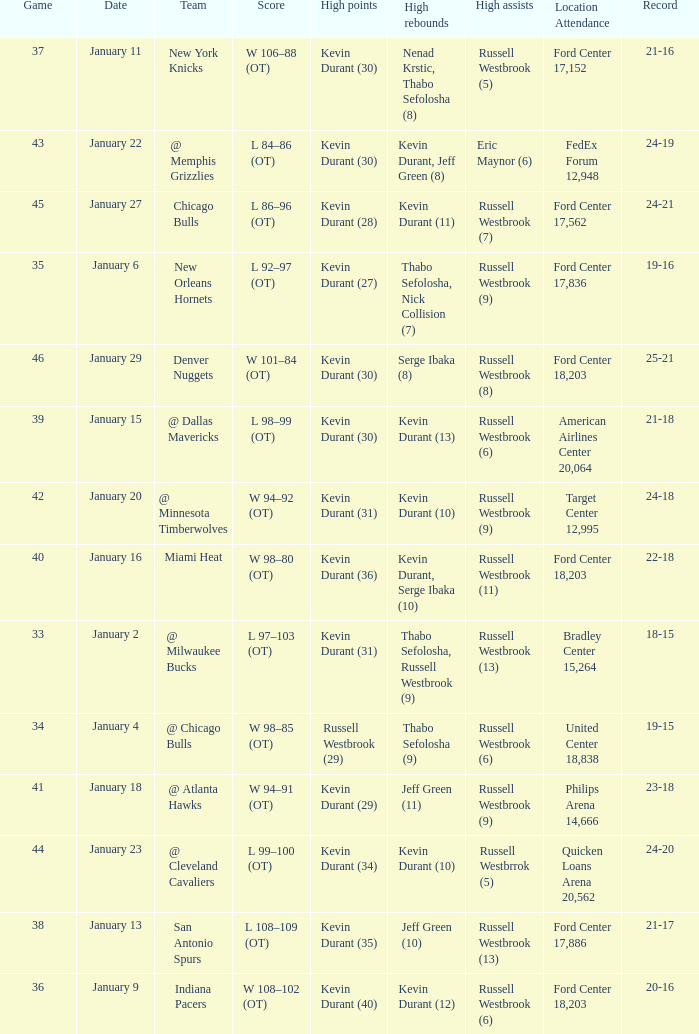Name the location attendance for january 18 Philips Arena 14,666. 